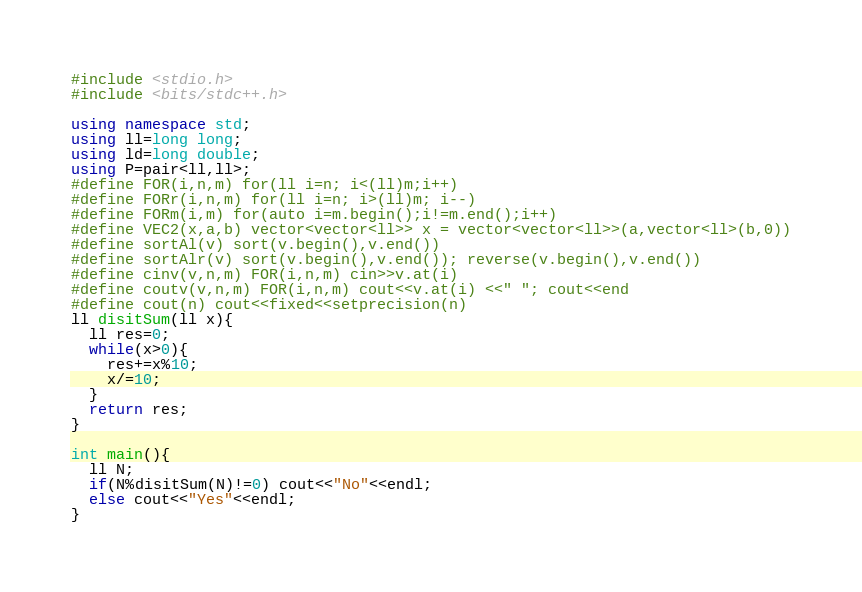<code> <loc_0><loc_0><loc_500><loc_500><_C++_>#include <stdio.h>
#include <bits/stdc++.h>

using namespace std;
using ll=long long;
using ld=long double;
using P=pair<ll,ll>;
#define FOR(i,n,m) for(ll i=n; i<(ll)m;i++)
#define FORr(i,n,m) for(ll i=n; i>(ll)m; i--)
#define FORm(i,m) for(auto i=m.begin();i!=m.end();i++)
#define VEC2(x,a,b) vector<vector<ll>> x = vector<vector<ll>>(a,vector<ll>(b,0))
#define sortAl(v) sort(v.begin(),v.end())
#define sortAlr(v) sort(v.begin(),v.end()); reverse(v.begin(),v.end())
#define cinv(v,n,m) FOR(i,n,m) cin>>v.at(i)
#define coutv(v,n,m) FOR(i,n,m) cout<<v.at(i) <<" "; cout<<end
#define cout(n) cout<<fixed<<setprecision(n)
ll disitSum(ll x){
  ll res=0;
  while(x>0){
    res+=x%10;
    x/=10;
  }
  return res;
}

int main(){
  ll N;
  if(N%disitSum(N)!=0) cout<<"No"<<endl;
  else cout<<"Yes"<<endl;
}
</code> 